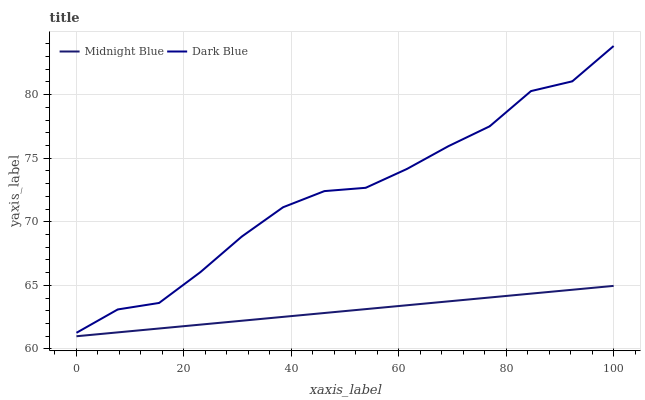Does Midnight Blue have the minimum area under the curve?
Answer yes or no. Yes. Does Dark Blue have the maximum area under the curve?
Answer yes or no. Yes. Does Midnight Blue have the maximum area under the curve?
Answer yes or no. No. Is Midnight Blue the smoothest?
Answer yes or no. Yes. Is Dark Blue the roughest?
Answer yes or no. Yes. Is Midnight Blue the roughest?
Answer yes or no. No. Does Dark Blue have the highest value?
Answer yes or no. Yes. Does Midnight Blue have the highest value?
Answer yes or no. No. Is Midnight Blue less than Dark Blue?
Answer yes or no. Yes. Is Dark Blue greater than Midnight Blue?
Answer yes or no. Yes. Does Midnight Blue intersect Dark Blue?
Answer yes or no. No. 